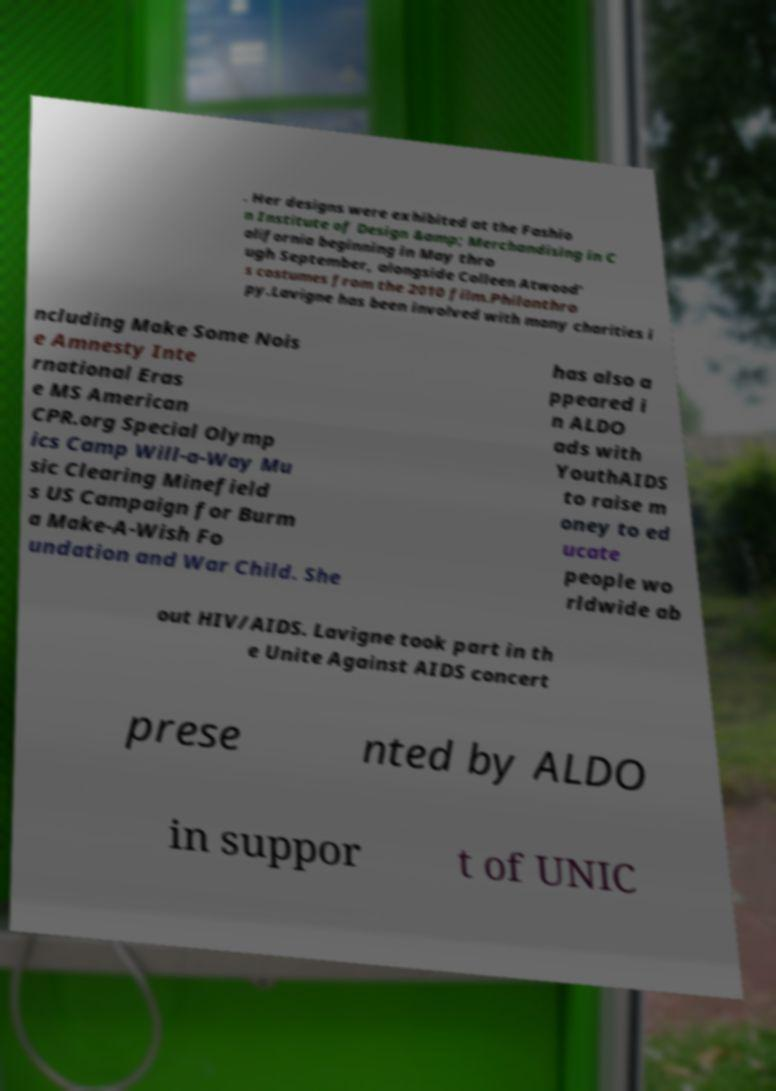What messages or text are displayed in this image? I need them in a readable, typed format. . Her designs were exhibited at the Fashio n Institute of Design &amp; Merchandising in C alifornia beginning in May thro ugh September, alongside Colleen Atwood' s costumes from the 2010 film.Philanthro py.Lavigne has been involved with many charities i ncluding Make Some Nois e Amnesty Inte rnational Eras e MS American CPR.org Special Olymp ics Camp Will-a-Way Mu sic Clearing Minefield s US Campaign for Burm a Make-A-Wish Fo undation and War Child. She has also a ppeared i n ALDO ads with YouthAIDS to raise m oney to ed ucate people wo rldwide ab out HIV/AIDS. Lavigne took part in th e Unite Against AIDS concert prese nted by ALDO in suppor t of UNIC 